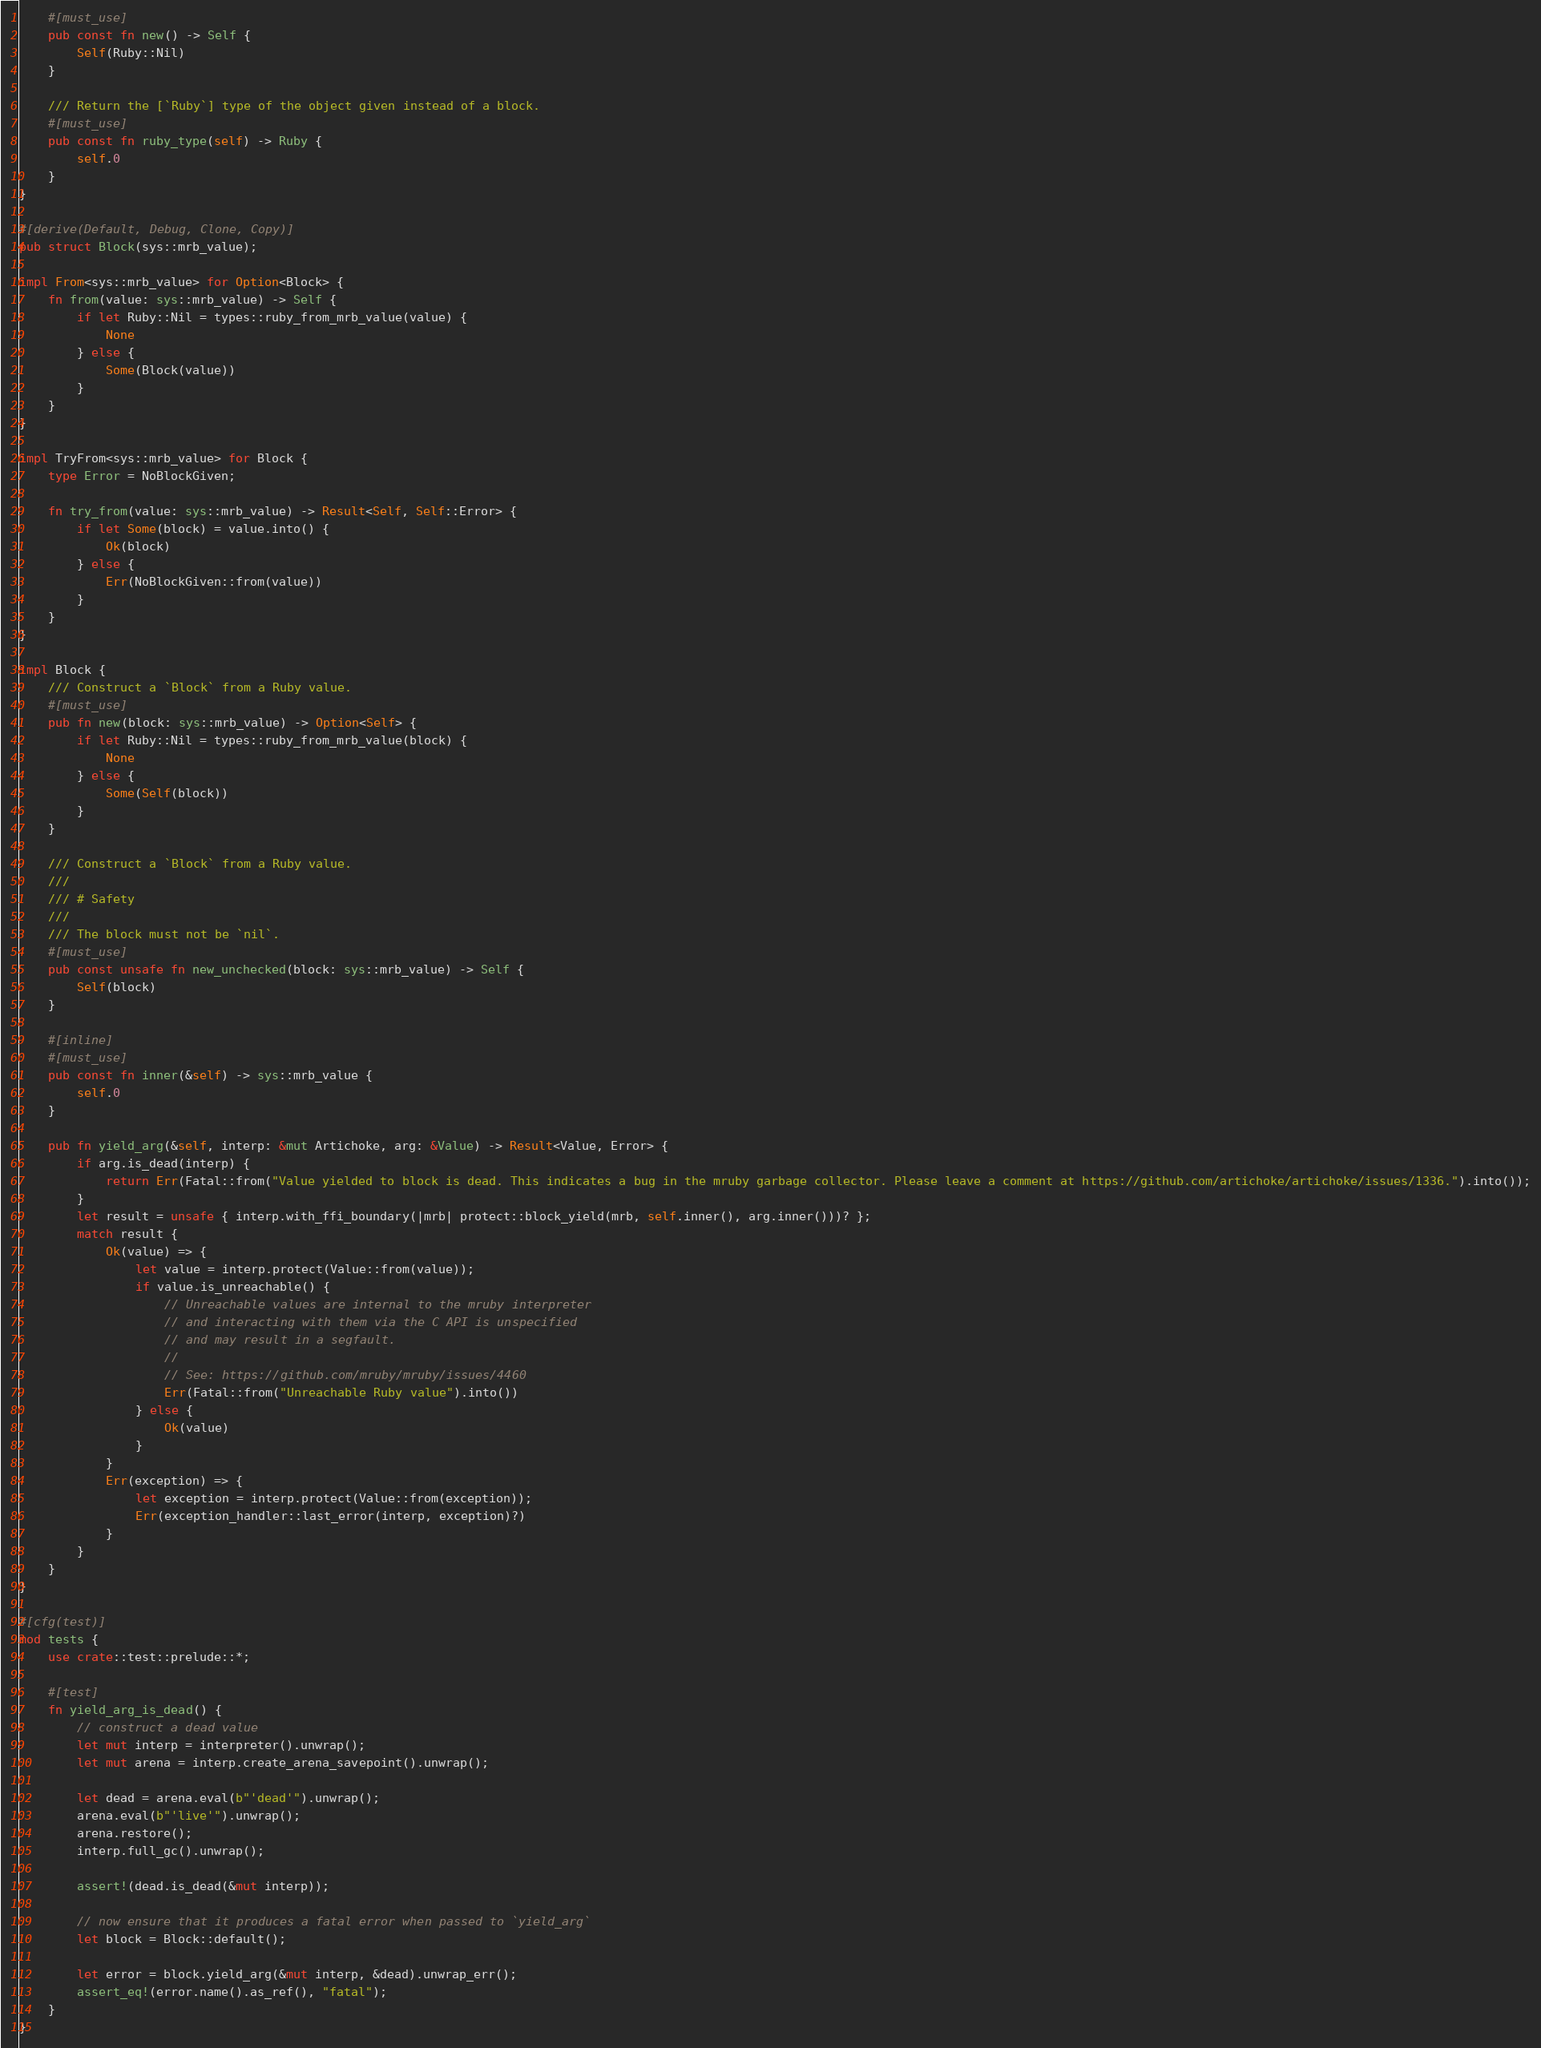Convert code to text. <code><loc_0><loc_0><loc_500><loc_500><_Rust_>    #[must_use]
    pub const fn new() -> Self {
        Self(Ruby::Nil)
    }

    /// Return the [`Ruby`] type of the object given instead of a block.
    #[must_use]
    pub const fn ruby_type(self) -> Ruby {
        self.0
    }
}

#[derive(Default, Debug, Clone, Copy)]
pub struct Block(sys::mrb_value);

impl From<sys::mrb_value> for Option<Block> {
    fn from(value: sys::mrb_value) -> Self {
        if let Ruby::Nil = types::ruby_from_mrb_value(value) {
            None
        } else {
            Some(Block(value))
        }
    }
}

impl TryFrom<sys::mrb_value> for Block {
    type Error = NoBlockGiven;

    fn try_from(value: sys::mrb_value) -> Result<Self, Self::Error> {
        if let Some(block) = value.into() {
            Ok(block)
        } else {
            Err(NoBlockGiven::from(value))
        }
    }
}

impl Block {
    /// Construct a `Block` from a Ruby value.
    #[must_use]
    pub fn new(block: sys::mrb_value) -> Option<Self> {
        if let Ruby::Nil = types::ruby_from_mrb_value(block) {
            None
        } else {
            Some(Self(block))
        }
    }

    /// Construct a `Block` from a Ruby value.
    ///
    /// # Safety
    ///
    /// The block must not be `nil`.
    #[must_use]
    pub const unsafe fn new_unchecked(block: sys::mrb_value) -> Self {
        Self(block)
    }

    #[inline]
    #[must_use]
    pub const fn inner(&self) -> sys::mrb_value {
        self.0
    }

    pub fn yield_arg(&self, interp: &mut Artichoke, arg: &Value) -> Result<Value, Error> {
        if arg.is_dead(interp) {
            return Err(Fatal::from("Value yielded to block is dead. This indicates a bug in the mruby garbage collector. Please leave a comment at https://github.com/artichoke/artichoke/issues/1336.").into());
        }
        let result = unsafe { interp.with_ffi_boundary(|mrb| protect::block_yield(mrb, self.inner(), arg.inner()))? };
        match result {
            Ok(value) => {
                let value = interp.protect(Value::from(value));
                if value.is_unreachable() {
                    // Unreachable values are internal to the mruby interpreter
                    // and interacting with them via the C API is unspecified
                    // and may result in a segfault.
                    //
                    // See: https://github.com/mruby/mruby/issues/4460
                    Err(Fatal::from("Unreachable Ruby value").into())
                } else {
                    Ok(value)
                }
            }
            Err(exception) => {
                let exception = interp.protect(Value::from(exception));
                Err(exception_handler::last_error(interp, exception)?)
            }
        }
    }
}

#[cfg(test)]
mod tests {
    use crate::test::prelude::*;

    #[test]
    fn yield_arg_is_dead() {
        // construct a dead value
        let mut interp = interpreter().unwrap();
        let mut arena = interp.create_arena_savepoint().unwrap();

        let dead = arena.eval(b"'dead'").unwrap();
        arena.eval(b"'live'").unwrap();
        arena.restore();
        interp.full_gc().unwrap();

        assert!(dead.is_dead(&mut interp));

        // now ensure that it produces a fatal error when passed to `yield_arg`
        let block = Block::default();

        let error = block.yield_arg(&mut interp, &dead).unwrap_err();
        assert_eq!(error.name().as_ref(), "fatal");
    }
}
</code> 